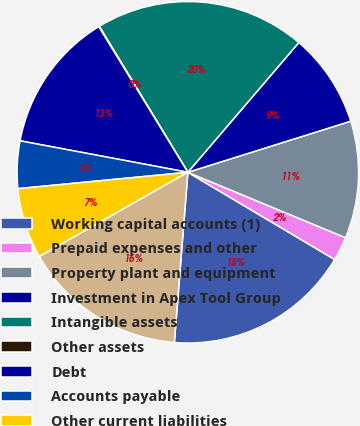Convert chart. <chart><loc_0><loc_0><loc_500><loc_500><pie_chart><fcel>Working capital accounts (1)<fcel>Prepaid expenses and other<fcel>Property plant and equipment<fcel>Investment in Apex Tool Group<fcel>Intangible assets<fcel>Other assets<fcel>Debt<fcel>Accounts payable<fcel>Other current liabilities<fcel>Other noncurrent liabilities<nl><fcel>17.73%<fcel>2.27%<fcel>11.1%<fcel>8.9%<fcel>19.94%<fcel>0.06%<fcel>13.31%<fcel>4.48%<fcel>6.69%<fcel>15.52%<nl></chart> 